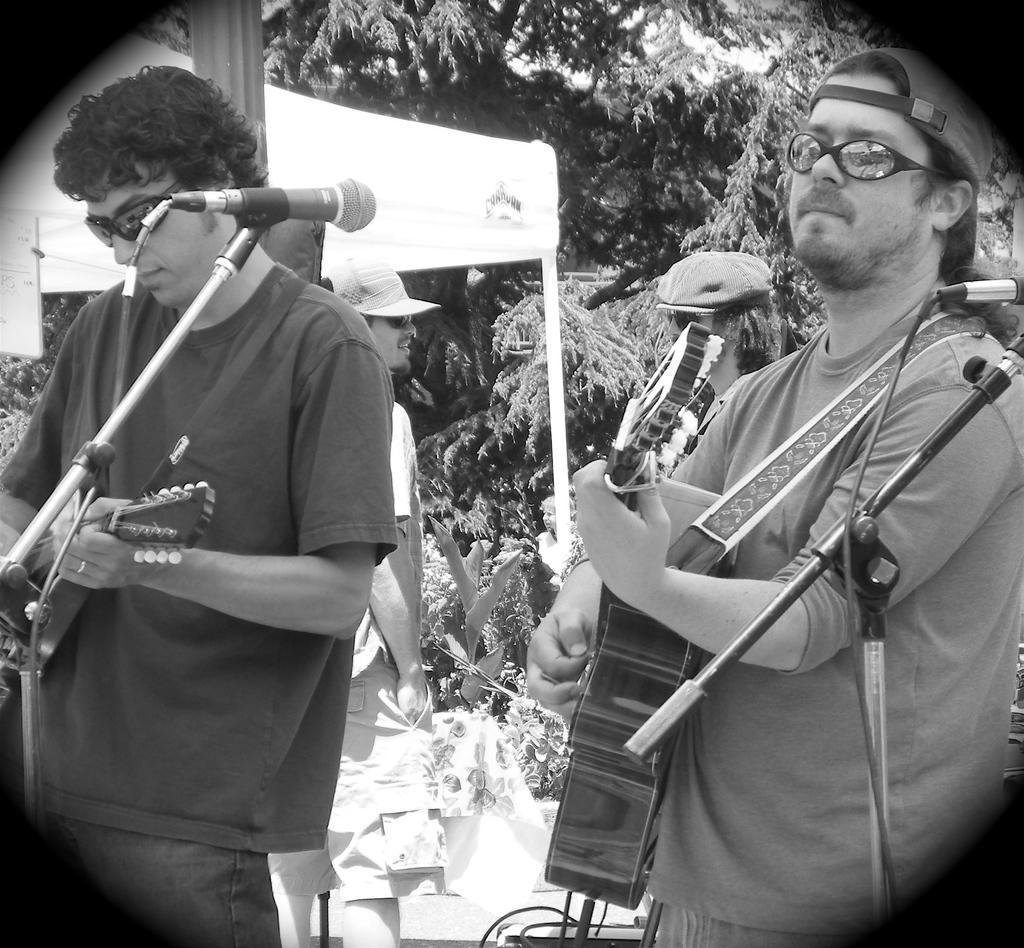Could you give a brief overview of what you see in this image? This is black and white picture,there are two men standing and playing guitar and we can see microphones with stands. In the background we can see trees,banner and people. 